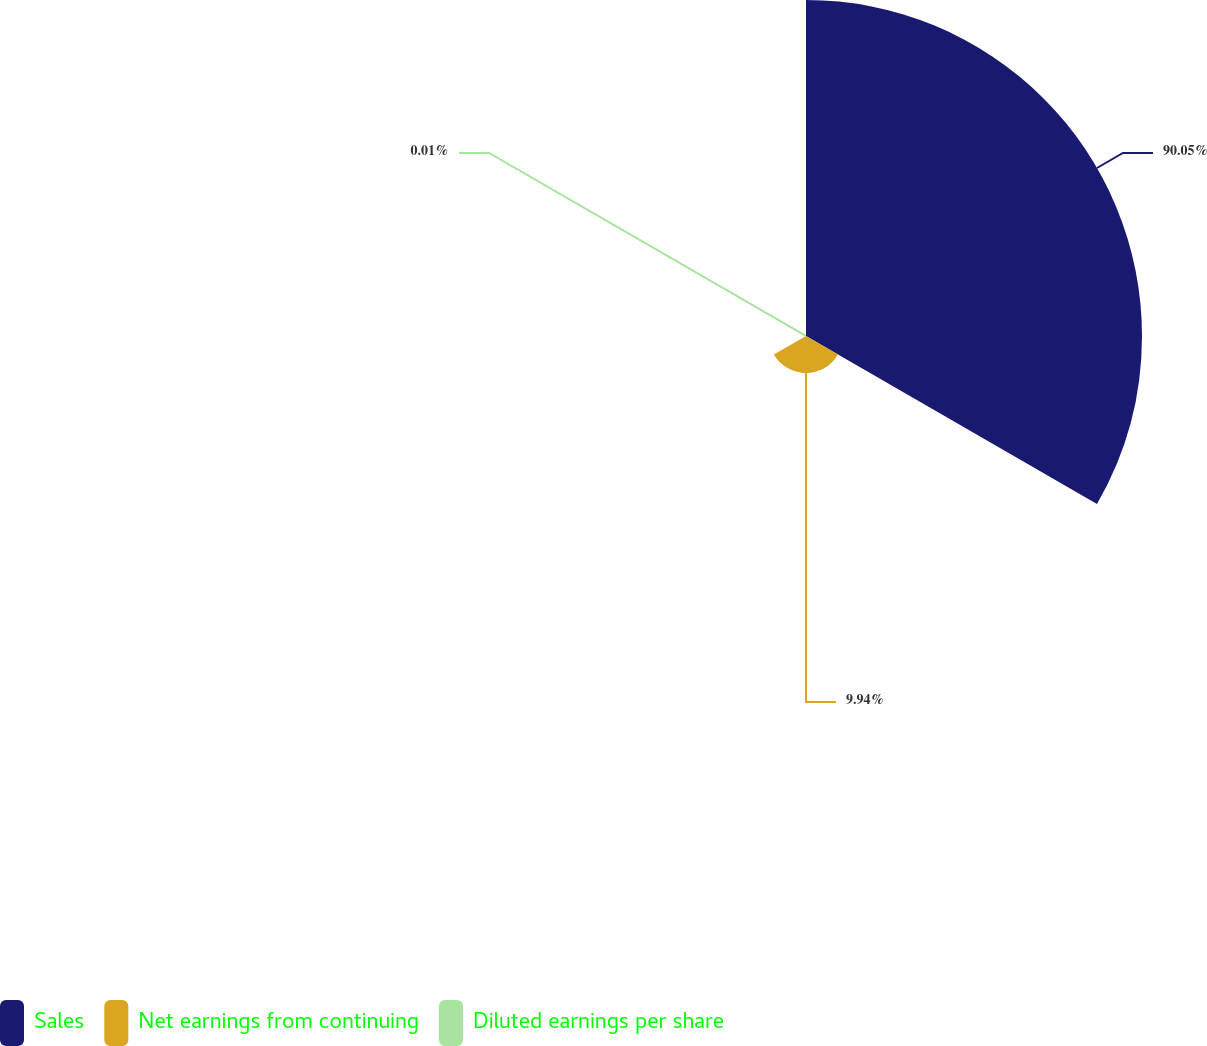Convert chart. <chart><loc_0><loc_0><loc_500><loc_500><pie_chart><fcel>Sales<fcel>Net earnings from continuing<fcel>Diluted earnings per share<nl><fcel>90.05%<fcel>9.94%<fcel>0.01%<nl></chart> 